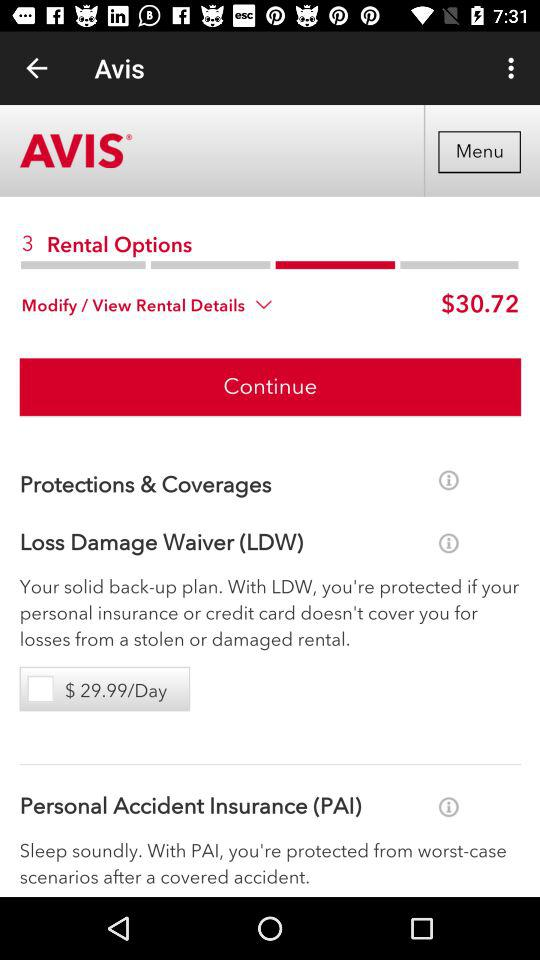What is the total amount for the rental? The total amount for the rental is $30.72. 